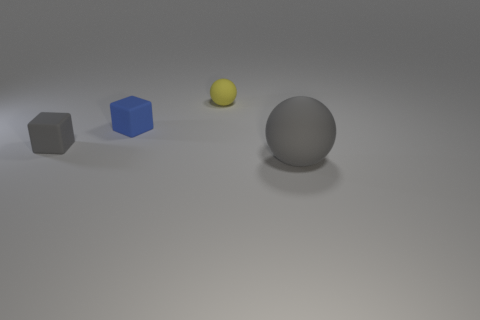There is a thing that is to the left of the tiny matte block behind the tiny matte cube that is in front of the small blue block; what is its size?
Your answer should be very brief. Small. Are there the same number of small yellow balls that are to the left of the yellow matte sphere and rubber objects in front of the blue rubber object?
Your answer should be very brief. No. What is the size of the gray ball that is the same material as the blue cube?
Provide a short and direct response. Large. What is the color of the small matte ball?
Ensure brevity in your answer.  Yellow. How many other small matte balls are the same color as the tiny rubber ball?
Ensure brevity in your answer.  0. There is a gray thing that is the same size as the yellow ball; what material is it?
Provide a succinct answer. Rubber. There is a sphere to the left of the big ball; is there a tiny sphere to the right of it?
Your answer should be very brief. No. How many other things are the same color as the big ball?
Your response must be concise. 1. What is the size of the gray block?
Your answer should be very brief. Small. Is there a small matte thing?
Provide a short and direct response. Yes. 